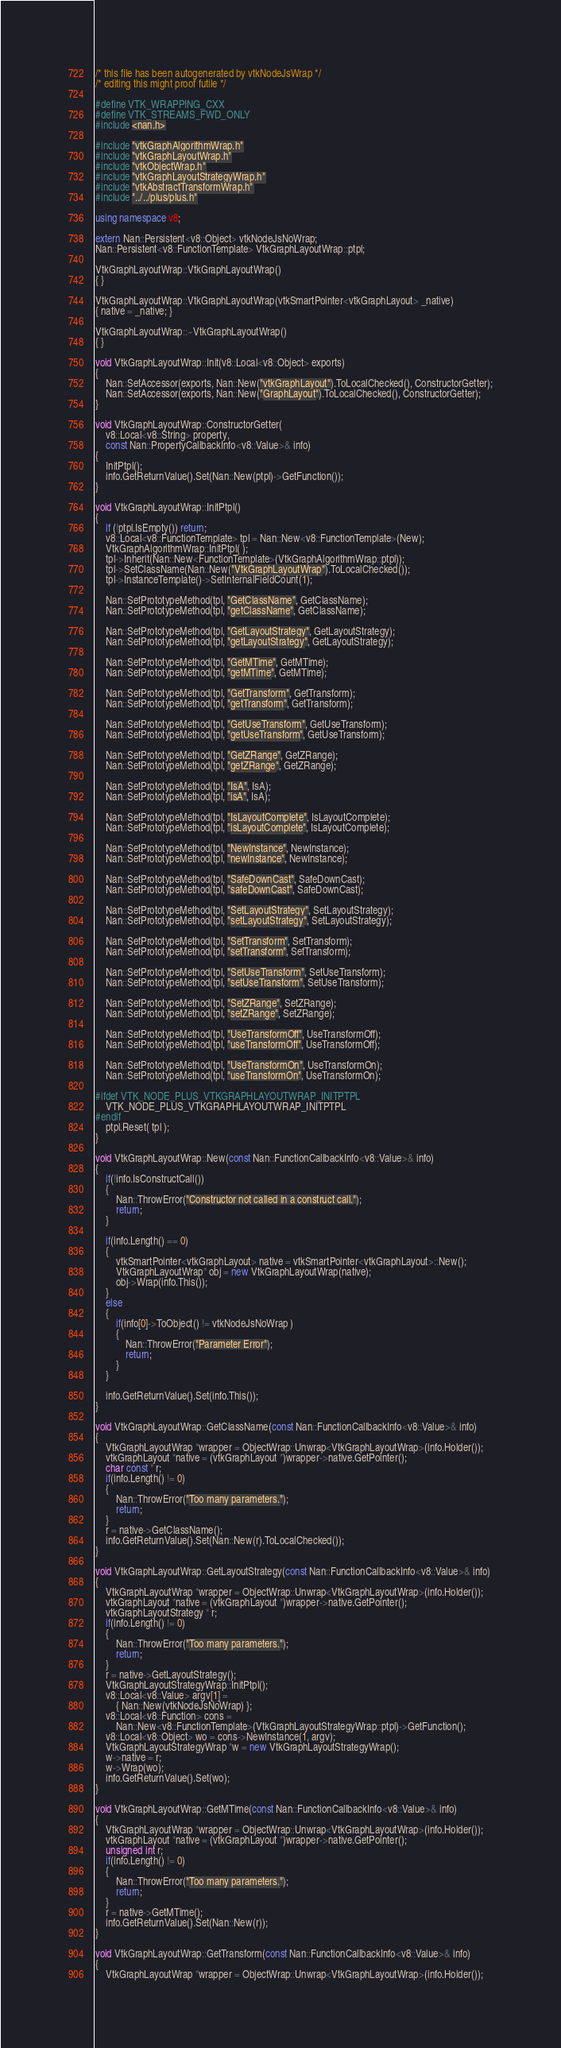Convert code to text. <code><loc_0><loc_0><loc_500><loc_500><_C++_>/* this file has been autogenerated by vtkNodeJsWrap */
/* editing this might proof futile */

#define VTK_WRAPPING_CXX
#define VTK_STREAMS_FWD_ONLY
#include <nan.h>

#include "vtkGraphAlgorithmWrap.h"
#include "vtkGraphLayoutWrap.h"
#include "vtkObjectWrap.h"
#include "vtkGraphLayoutStrategyWrap.h"
#include "vtkAbstractTransformWrap.h"
#include "../../plus/plus.h"

using namespace v8;

extern Nan::Persistent<v8::Object> vtkNodeJsNoWrap;
Nan::Persistent<v8::FunctionTemplate> VtkGraphLayoutWrap::ptpl;

VtkGraphLayoutWrap::VtkGraphLayoutWrap()
{ }

VtkGraphLayoutWrap::VtkGraphLayoutWrap(vtkSmartPointer<vtkGraphLayout> _native)
{ native = _native; }

VtkGraphLayoutWrap::~VtkGraphLayoutWrap()
{ }

void VtkGraphLayoutWrap::Init(v8::Local<v8::Object> exports)
{
	Nan::SetAccessor(exports, Nan::New("vtkGraphLayout").ToLocalChecked(), ConstructorGetter);
	Nan::SetAccessor(exports, Nan::New("GraphLayout").ToLocalChecked(), ConstructorGetter);
}

void VtkGraphLayoutWrap::ConstructorGetter(
	v8::Local<v8::String> property,
	const Nan::PropertyCallbackInfo<v8::Value>& info)
{
	InitPtpl();
	info.GetReturnValue().Set(Nan::New(ptpl)->GetFunction());
}

void VtkGraphLayoutWrap::InitPtpl()
{
	if (!ptpl.IsEmpty()) return;
	v8::Local<v8::FunctionTemplate> tpl = Nan::New<v8::FunctionTemplate>(New);
	VtkGraphAlgorithmWrap::InitPtpl( );
	tpl->Inherit(Nan::New<FunctionTemplate>(VtkGraphAlgorithmWrap::ptpl));
	tpl->SetClassName(Nan::New("VtkGraphLayoutWrap").ToLocalChecked());
	tpl->InstanceTemplate()->SetInternalFieldCount(1);

	Nan::SetPrototypeMethod(tpl, "GetClassName", GetClassName);
	Nan::SetPrototypeMethod(tpl, "getClassName", GetClassName);

	Nan::SetPrototypeMethod(tpl, "GetLayoutStrategy", GetLayoutStrategy);
	Nan::SetPrototypeMethod(tpl, "getLayoutStrategy", GetLayoutStrategy);

	Nan::SetPrototypeMethod(tpl, "GetMTime", GetMTime);
	Nan::SetPrototypeMethod(tpl, "getMTime", GetMTime);

	Nan::SetPrototypeMethod(tpl, "GetTransform", GetTransform);
	Nan::SetPrototypeMethod(tpl, "getTransform", GetTransform);

	Nan::SetPrototypeMethod(tpl, "GetUseTransform", GetUseTransform);
	Nan::SetPrototypeMethod(tpl, "getUseTransform", GetUseTransform);

	Nan::SetPrototypeMethod(tpl, "GetZRange", GetZRange);
	Nan::SetPrototypeMethod(tpl, "getZRange", GetZRange);

	Nan::SetPrototypeMethod(tpl, "IsA", IsA);
	Nan::SetPrototypeMethod(tpl, "isA", IsA);

	Nan::SetPrototypeMethod(tpl, "IsLayoutComplete", IsLayoutComplete);
	Nan::SetPrototypeMethod(tpl, "isLayoutComplete", IsLayoutComplete);

	Nan::SetPrototypeMethod(tpl, "NewInstance", NewInstance);
	Nan::SetPrototypeMethod(tpl, "newInstance", NewInstance);

	Nan::SetPrototypeMethod(tpl, "SafeDownCast", SafeDownCast);
	Nan::SetPrototypeMethod(tpl, "safeDownCast", SafeDownCast);

	Nan::SetPrototypeMethod(tpl, "SetLayoutStrategy", SetLayoutStrategy);
	Nan::SetPrototypeMethod(tpl, "setLayoutStrategy", SetLayoutStrategy);

	Nan::SetPrototypeMethod(tpl, "SetTransform", SetTransform);
	Nan::SetPrototypeMethod(tpl, "setTransform", SetTransform);

	Nan::SetPrototypeMethod(tpl, "SetUseTransform", SetUseTransform);
	Nan::SetPrototypeMethod(tpl, "setUseTransform", SetUseTransform);

	Nan::SetPrototypeMethod(tpl, "SetZRange", SetZRange);
	Nan::SetPrototypeMethod(tpl, "setZRange", SetZRange);

	Nan::SetPrototypeMethod(tpl, "UseTransformOff", UseTransformOff);
	Nan::SetPrototypeMethod(tpl, "useTransformOff", UseTransformOff);

	Nan::SetPrototypeMethod(tpl, "UseTransformOn", UseTransformOn);
	Nan::SetPrototypeMethod(tpl, "useTransformOn", UseTransformOn);

#ifdef VTK_NODE_PLUS_VTKGRAPHLAYOUTWRAP_INITPTPL
	VTK_NODE_PLUS_VTKGRAPHLAYOUTWRAP_INITPTPL
#endif
	ptpl.Reset( tpl );
}

void VtkGraphLayoutWrap::New(const Nan::FunctionCallbackInfo<v8::Value>& info)
{
	if(!info.IsConstructCall())
	{
		Nan::ThrowError("Constructor not called in a construct call.");
		return;
	}

	if(info.Length() == 0)
	{
		vtkSmartPointer<vtkGraphLayout> native = vtkSmartPointer<vtkGraphLayout>::New();
		VtkGraphLayoutWrap* obj = new VtkGraphLayoutWrap(native);
		obj->Wrap(info.This());
	}
	else
	{
		if(info[0]->ToObject() != vtkNodeJsNoWrap )
		{
			Nan::ThrowError("Parameter Error");
			return;
		}
	}

	info.GetReturnValue().Set(info.This());
}

void VtkGraphLayoutWrap::GetClassName(const Nan::FunctionCallbackInfo<v8::Value>& info)
{
	VtkGraphLayoutWrap *wrapper = ObjectWrap::Unwrap<VtkGraphLayoutWrap>(info.Holder());
	vtkGraphLayout *native = (vtkGraphLayout *)wrapper->native.GetPointer();
	char const * r;
	if(info.Length() != 0)
	{
		Nan::ThrowError("Too many parameters.");
		return;
	}
	r = native->GetClassName();
	info.GetReturnValue().Set(Nan::New(r).ToLocalChecked());
}

void VtkGraphLayoutWrap::GetLayoutStrategy(const Nan::FunctionCallbackInfo<v8::Value>& info)
{
	VtkGraphLayoutWrap *wrapper = ObjectWrap::Unwrap<VtkGraphLayoutWrap>(info.Holder());
	vtkGraphLayout *native = (vtkGraphLayout *)wrapper->native.GetPointer();
	vtkGraphLayoutStrategy * r;
	if(info.Length() != 0)
	{
		Nan::ThrowError("Too many parameters.");
		return;
	}
	r = native->GetLayoutStrategy();
	VtkGraphLayoutStrategyWrap::InitPtpl();
	v8::Local<v8::Value> argv[1] =
		{ Nan::New(vtkNodeJsNoWrap) };
	v8::Local<v8::Function> cons =
		Nan::New<v8::FunctionTemplate>(VtkGraphLayoutStrategyWrap::ptpl)->GetFunction();
	v8::Local<v8::Object> wo = cons->NewInstance(1, argv);
	VtkGraphLayoutStrategyWrap *w = new VtkGraphLayoutStrategyWrap();
	w->native = r;
	w->Wrap(wo);
	info.GetReturnValue().Set(wo);
}

void VtkGraphLayoutWrap::GetMTime(const Nan::FunctionCallbackInfo<v8::Value>& info)
{
	VtkGraphLayoutWrap *wrapper = ObjectWrap::Unwrap<VtkGraphLayoutWrap>(info.Holder());
	vtkGraphLayout *native = (vtkGraphLayout *)wrapper->native.GetPointer();
	unsigned int r;
	if(info.Length() != 0)
	{
		Nan::ThrowError("Too many parameters.");
		return;
	}
	r = native->GetMTime();
	info.GetReturnValue().Set(Nan::New(r));
}

void VtkGraphLayoutWrap::GetTransform(const Nan::FunctionCallbackInfo<v8::Value>& info)
{
	VtkGraphLayoutWrap *wrapper = ObjectWrap::Unwrap<VtkGraphLayoutWrap>(info.Holder());</code> 